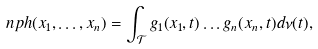<formula> <loc_0><loc_0><loc_500><loc_500>\ n p h ( x _ { 1 } , \dots , x _ { n } ) = \int _ { \mathcal { T } } g _ { 1 } ( x _ { 1 } , t ) \dots g _ { n } ( x _ { n } , t ) d \nu ( t ) ,</formula> 